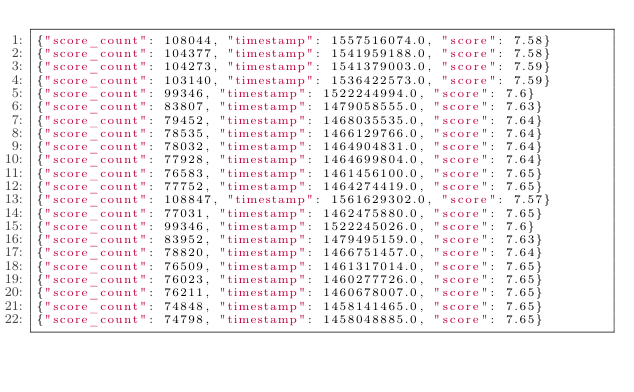<code> <loc_0><loc_0><loc_500><loc_500><_Julia_>{"score_count": 108044, "timestamp": 1557516074.0, "score": 7.58}
{"score_count": 104377, "timestamp": 1541959188.0, "score": 7.58}
{"score_count": 104273, "timestamp": 1541379003.0, "score": 7.59}
{"score_count": 103140, "timestamp": 1536422573.0, "score": 7.59}
{"score_count": 99346, "timestamp": 1522244994.0, "score": 7.6}
{"score_count": 83807, "timestamp": 1479058555.0, "score": 7.63}
{"score_count": 79452, "timestamp": 1468035535.0, "score": 7.64}
{"score_count": 78535, "timestamp": 1466129766.0, "score": 7.64}
{"score_count": 78032, "timestamp": 1464904831.0, "score": 7.64}
{"score_count": 77928, "timestamp": 1464699804.0, "score": 7.64}
{"score_count": 76583, "timestamp": 1461456100.0, "score": 7.65}
{"score_count": 77752, "timestamp": 1464274419.0, "score": 7.65}
{"score_count": 108847, "timestamp": 1561629302.0, "score": 7.57}
{"score_count": 77031, "timestamp": 1462475880.0, "score": 7.65}
{"score_count": 99346, "timestamp": 1522245026.0, "score": 7.6}
{"score_count": 83952, "timestamp": 1479495159.0, "score": 7.63}
{"score_count": 78820, "timestamp": 1466751457.0, "score": 7.64}
{"score_count": 76509, "timestamp": 1461317014.0, "score": 7.65}
{"score_count": 76023, "timestamp": 1460277726.0, "score": 7.65}
{"score_count": 76211, "timestamp": 1460678007.0, "score": 7.65}
{"score_count": 74848, "timestamp": 1458141465.0, "score": 7.65}
{"score_count": 74798, "timestamp": 1458048885.0, "score": 7.65}</code> 